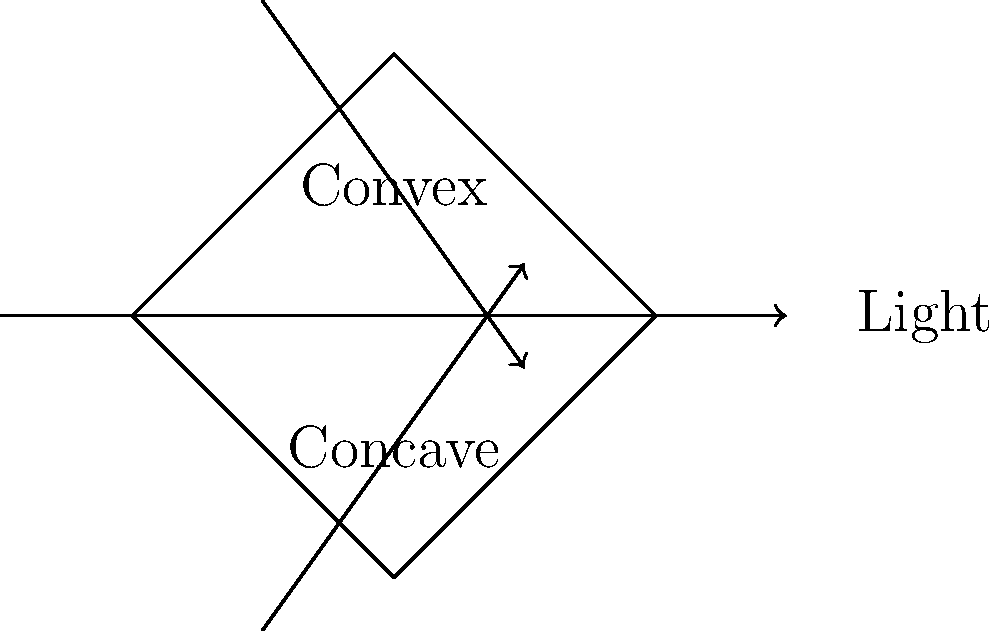As a refractive surgeon, you understand the importance of lens shapes in correcting vision. Consider the diagram showing convex and concave lenses. When parallel light rays pass through these lenses, how does the refraction differ, and what effect does this have on the focal point of each lens type? To understand the refraction through convex and concave lenses, let's break it down step-by-step:

1. Convex lens:
   a) Light rays passing through the center of the lens continue straight.
   b) Rays passing through the edges are bent towards the optical axis.
   c) This causes the light rays to converge at a point called the focal point.
   d) The focal length (f) is positive for convex lenses.

2. Concave lens:
   a) Light rays passing through the center of the lens continue straight.
   b) Rays passing through the edges are bent away from the optical axis.
   c) This causes the light rays to diverge.
   d) The focal length (f) is negative for concave lenses.

3. The thin lens equation relates object distance (do), image distance (di), and focal length (f):
   $$\frac{1}{f} = \frac{1}{d_o} + \frac{1}{d_i}$$

4. For convex lenses:
   a) Real images are formed when the object is beyond the focal point.
   b) Virtual images are formed when the object is within the focal point.

5. For concave lenses:
   a) Only virtual images are formed, regardless of object position.

6. In vision correction:
   a) Convex lenses are used to correct farsightedness (hyperopia).
   b) Concave lenses are used to correct nearsightedness (myopia).

The key difference is that convex lenses cause light rays to converge to a real focal point, while concave lenses cause light rays to diverge from a virtual focal point.
Answer: Convex lenses converge light to a real focal point; concave lenses diverge light from a virtual focal point. 